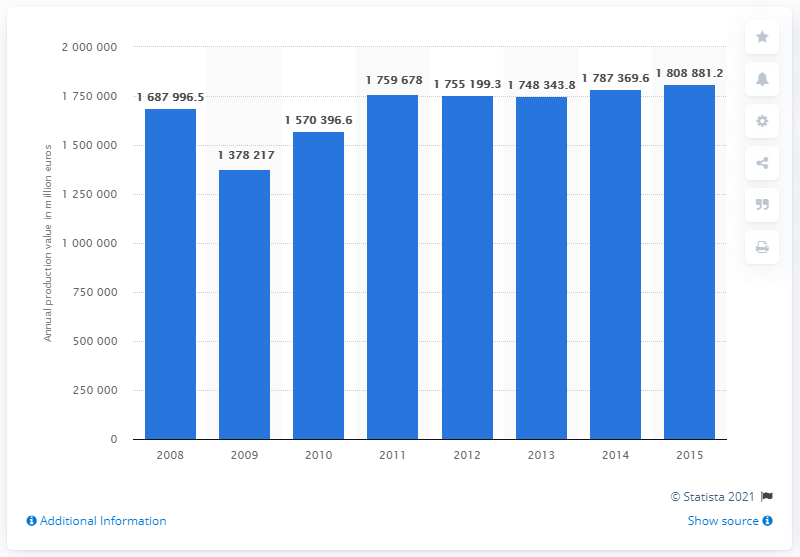Identify some key points in this picture. In 2015, the annual production value of the manufacturing industry in Germany was 180,888,123.2 euros. 